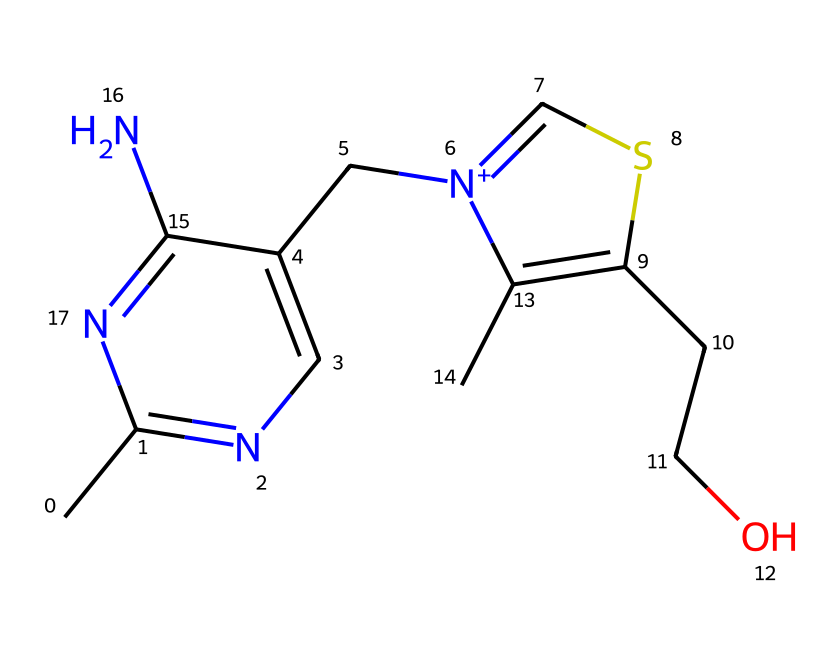What is the molecular formula of thiamine? By analyzing the SMILES representation, we can determine the molecular formula by counting the atoms of each element present: C (carbon), H (hydrogen), N (nitrogen), and S (sulfur). The chemical contains 12 carbon atoms, 17 hydrogen atoms, 2 nitrogen atoms, and 1 sulfur atom.
Answer: C12H17N2OS How many nitrogen atoms are in the thiamine structure? The SMILES notation shows two 'n' symbols, which represent nitrogen atoms. Therefore, by identifying these symbols, we can conclude the total number of nitrogen atoms in the structure.
Answer: 2 What functional group in thiamine indicates its classification as an organosulfur compound? The presence of the sulfur atom in the SMILES structure signifies that thiamine contains a sulfonyl functional group, making it an organosulfur compound. The 'S' in the notation clearly represents that functional group.
Answer: sulfonyl How many rings are present in the thiamine structure? The SMILES indicates cyclic structures through the use of 'c' and 'C' notations. By reviewing the entire sequence, we find two rings present within the structure.
Answer: 2 Which elements are directly contributing to thiamine's role in cognitive function? The nitrogen and sulfur atoms in thiamine are crucial for its biochemical functions, including its role as a coenzyme in cellular processes related to cognitive function. Therefore, both nitrogen and sulfur play important roles in these biochemical activities.
Answer: nitrogen and sulfur What type of bonding is most likely present between the carbon and nitrogen atoms in thiamine? The carbon atoms bond with nitrogen atoms primarily through covalent bonds, as organic compounds like thiamine typically exhibit covalent bonding characteristics for stability and functionality.
Answer: covalent 